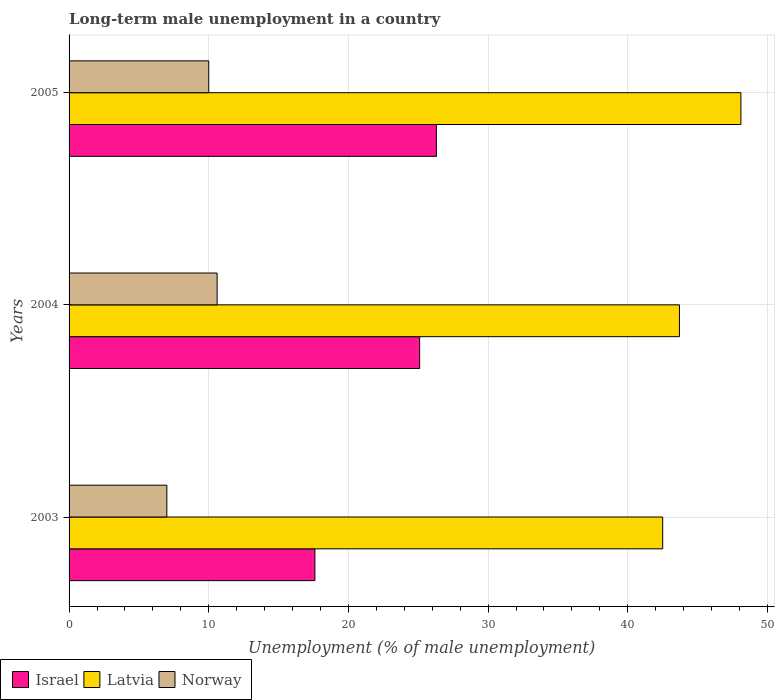How many different coloured bars are there?
Offer a very short reply. 3. How many bars are there on the 3rd tick from the bottom?
Your answer should be compact. 3. What is the label of the 1st group of bars from the top?
Provide a short and direct response. 2005. In how many cases, is the number of bars for a given year not equal to the number of legend labels?
Ensure brevity in your answer.  0. What is the percentage of long-term unemployed male population in Israel in 2003?
Offer a terse response. 17.6. Across all years, what is the maximum percentage of long-term unemployed male population in Latvia?
Offer a very short reply. 48.1. Across all years, what is the minimum percentage of long-term unemployed male population in Israel?
Your answer should be compact. 17.6. In which year was the percentage of long-term unemployed male population in Norway maximum?
Provide a succinct answer. 2004. What is the total percentage of long-term unemployed male population in Israel in the graph?
Provide a succinct answer. 69. What is the difference between the percentage of long-term unemployed male population in Israel in 2004 and that in 2005?
Provide a short and direct response. -1.2. What is the difference between the percentage of long-term unemployed male population in Latvia in 2004 and the percentage of long-term unemployed male population in Norway in 2003?
Your answer should be compact. 36.7. What is the average percentage of long-term unemployed male population in Latvia per year?
Make the answer very short. 44.77. In the year 2004, what is the difference between the percentage of long-term unemployed male population in Israel and percentage of long-term unemployed male population in Latvia?
Keep it short and to the point. -18.6. In how many years, is the percentage of long-term unemployed male population in Latvia greater than 2 %?
Offer a very short reply. 3. What is the ratio of the percentage of long-term unemployed male population in Latvia in 2003 to that in 2004?
Provide a short and direct response. 0.97. What is the difference between the highest and the second highest percentage of long-term unemployed male population in Israel?
Your answer should be compact. 1.2. What is the difference between the highest and the lowest percentage of long-term unemployed male population in Norway?
Ensure brevity in your answer.  3.6. Is the sum of the percentage of long-term unemployed male population in Israel in 2003 and 2005 greater than the maximum percentage of long-term unemployed male population in Latvia across all years?
Your response must be concise. No. How many bars are there?
Ensure brevity in your answer.  9. Are all the bars in the graph horizontal?
Your response must be concise. Yes. Does the graph contain grids?
Ensure brevity in your answer.  Yes. How many legend labels are there?
Make the answer very short. 3. How are the legend labels stacked?
Your response must be concise. Horizontal. What is the title of the graph?
Your answer should be compact. Long-term male unemployment in a country. What is the label or title of the X-axis?
Your response must be concise. Unemployment (% of male unemployment). What is the label or title of the Y-axis?
Make the answer very short. Years. What is the Unemployment (% of male unemployment) in Israel in 2003?
Offer a very short reply. 17.6. What is the Unemployment (% of male unemployment) in Latvia in 2003?
Provide a succinct answer. 42.5. What is the Unemployment (% of male unemployment) of Norway in 2003?
Give a very brief answer. 7. What is the Unemployment (% of male unemployment) of Israel in 2004?
Provide a succinct answer. 25.1. What is the Unemployment (% of male unemployment) in Latvia in 2004?
Ensure brevity in your answer.  43.7. What is the Unemployment (% of male unemployment) in Norway in 2004?
Provide a succinct answer. 10.6. What is the Unemployment (% of male unemployment) of Israel in 2005?
Keep it short and to the point. 26.3. What is the Unemployment (% of male unemployment) of Latvia in 2005?
Provide a succinct answer. 48.1. What is the Unemployment (% of male unemployment) in Norway in 2005?
Your response must be concise. 10. Across all years, what is the maximum Unemployment (% of male unemployment) of Israel?
Keep it short and to the point. 26.3. Across all years, what is the maximum Unemployment (% of male unemployment) in Latvia?
Ensure brevity in your answer.  48.1. Across all years, what is the maximum Unemployment (% of male unemployment) in Norway?
Your answer should be compact. 10.6. Across all years, what is the minimum Unemployment (% of male unemployment) in Israel?
Make the answer very short. 17.6. Across all years, what is the minimum Unemployment (% of male unemployment) of Latvia?
Provide a short and direct response. 42.5. Across all years, what is the minimum Unemployment (% of male unemployment) in Norway?
Your answer should be compact. 7. What is the total Unemployment (% of male unemployment) in Israel in the graph?
Your answer should be compact. 69. What is the total Unemployment (% of male unemployment) of Latvia in the graph?
Offer a very short reply. 134.3. What is the total Unemployment (% of male unemployment) in Norway in the graph?
Your answer should be compact. 27.6. What is the difference between the Unemployment (% of male unemployment) of Latvia in 2003 and that in 2004?
Your answer should be compact. -1.2. What is the difference between the Unemployment (% of male unemployment) in Norway in 2003 and that in 2004?
Give a very brief answer. -3.6. What is the difference between the Unemployment (% of male unemployment) of Israel in 2003 and that in 2005?
Provide a short and direct response. -8.7. What is the difference between the Unemployment (% of male unemployment) in Latvia in 2003 and that in 2005?
Give a very brief answer. -5.6. What is the difference between the Unemployment (% of male unemployment) in Israel in 2003 and the Unemployment (% of male unemployment) in Latvia in 2004?
Provide a short and direct response. -26.1. What is the difference between the Unemployment (% of male unemployment) in Israel in 2003 and the Unemployment (% of male unemployment) in Norway in 2004?
Keep it short and to the point. 7. What is the difference between the Unemployment (% of male unemployment) in Latvia in 2003 and the Unemployment (% of male unemployment) in Norway in 2004?
Ensure brevity in your answer.  31.9. What is the difference between the Unemployment (% of male unemployment) of Israel in 2003 and the Unemployment (% of male unemployment) of Latvia in 2005?
Your answer should be very brief. -30.5. What is the difference between the Unemployment (% of male unemployment) in Latvia in 2003 and the Unemployment (% of male unemployment) in Norway in 2005?
Ensure brevity in your answer.  32.5. What is the difference between the Unemployment (% of male unemployment) of Latvia in 2004 and the Unemployment (% of male unemployment) of Norway in 2005?
Offer a terse response. 33.7. What is the average Unemployment (% of male unemployment) in Israel per year?
Your answer should be compact. 23. What is the average Unemployment (% of male unemployment) in Latvia per year?
Your answer should be compact. 44.77. What is the average Unemployment (% of male unemployment) in Norway per year?
Offer a terse response. 9.2. In the year 2003, what is the difference between the Unemployment (% of male unemployment) of Israel and Unemployment (% of male unemployment) of Latvia?
Ensure brevity in your answer.  -24.9. In the year 2003, what is the difference between the Unemployment (% of male unemployment) in Israel and Unemployment (% of male unemployment) in Norway?
Your answer should be very brief. 10.6. In the year 2003, what is the difference between the Unemployment (% of male unemployment) of Latvia and Unemployment (% of male unemployment) of Norway?
Your answer should be very brief. 35.5. In the year 2004, what is the difference between the Unemployment (% of male unemployment) of Israel and Unemployment (% of male unemployment) of Latvia?
Give a very brief answer. -18.6. In the year 2004, what is the difference between the Unemployment (% of male unemployment) of Latvia and Unemployment (% of male unemployment) of Norway?
Offer a terse response. 33.1. In the year 2005, what is the difference between the Unemployment (% of male unemployment) in Israel and Unemployment (% of male unemployment) in Latvia?
Provide a short and direct response. -21.8. In the year 2005, what is the difference between the Unemployment (% of male unemployment) in Israel and Unemployment (% of male unemployment) in Norway?
Give a very brief answer. 16.3. In the year 2005, what is the difference between the Unemployment (% of male unemployment) in Latvia and Unemployment (% of male unemployment) in Norway?
Make the answer very short. 38.1. What is the ratio of the Unemployment (% of male unemployment) in Israel in 2003 to that in 2004?
Make the answer very short. 0.7. What is the ratio of the Unemployment (% of male unemployment) in Latvia in 2003 to that in 2004?
Your response must be concise. 0.97. What is the ratio of the Unemployment (% of male unemployment) of Norway in 2003 to that in 2004?
Offer a terse response. 0.66. What is the ratio of the Unemployment (% of male unemployment) of Israel in 2003 to that in 2005?
Make the answer very short. 0.67. What is the ratio of the Unemployment (% of male unemployment) of Latvia in 2003 to that in 2005?
Offer a terse response. 0.88. What is the ratio of the Unemployment (% of male unemployment) of Israel in 2004 to that in 2005?
Provide a short and direct response. 0.95. What is the ratio of the Unemployment (% of male unemployment) in Latvia in 2004 to that in 2005?
Offer a terse response. 0.91. What is the ratio of the Unemployment (% of male unemployment) of Norway in 2004 to that in 2005?
Keep it short and to the point. 1.06. What is the difference between the highest and the second highest Unemployment (% of male unemployment) in Israel?
Your answer should be very brief. 1.2. What is the difference between the highest and the second highest Unemployment (% of male unemployment) of Norway?
Offer a terse response. 0.6. What is the difference between the highest and the lowest Unemployment (% of male unemployment) in Latvia?
Keep it short and to the point. 5.6. What is the difference between the highest and the lowest Unemployment (% of male unemployment) in Norway?
Give a very brief answer. 3.6. 